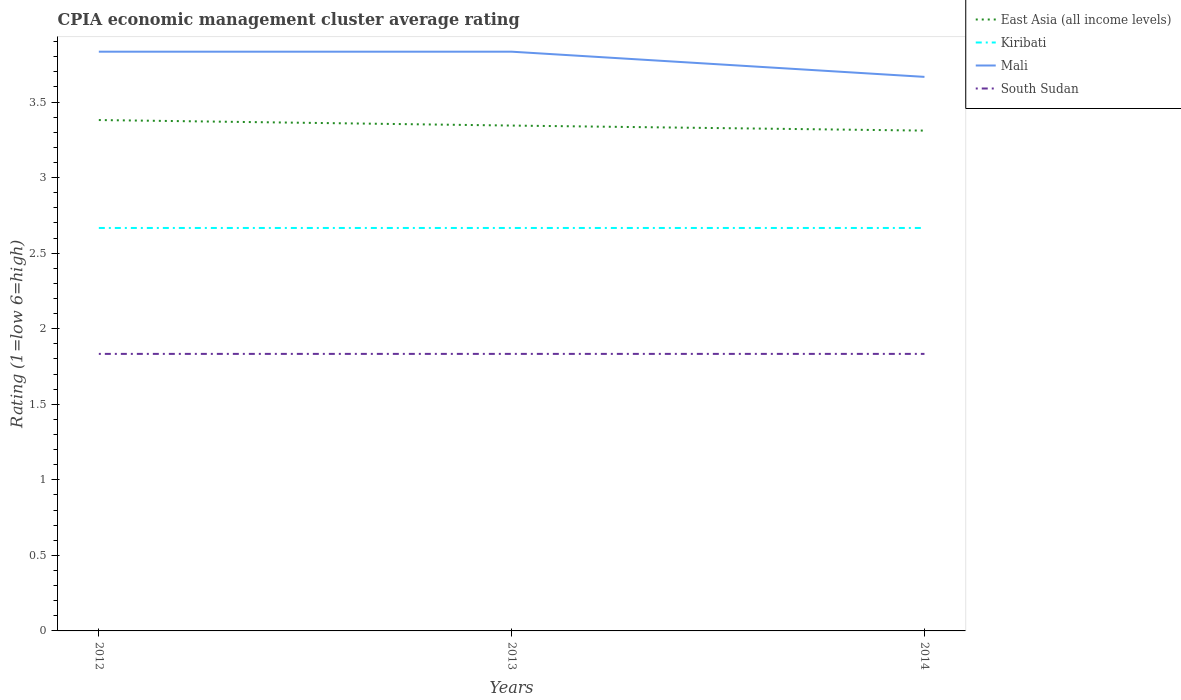Does the line corresponding to Mali intersect with the line corresponding to Kiribati?
Give a very brief answer. No. Is the number of lines equal to the number of legend labels?
Your answer should be very brief. Yes. Across all years, what is the maximum CPIA rating in East Asia (all income levels)?
Ensure brevity in your answer.  3.31. What is the total CPIA rating in Mali in the graph?
Ensure brevity in your answer.  0.17. What is the difference between the highest and the second highest CPIA rating in South Sudan?
Your answer should be very brief. 3.3333333300245016e-6. What is the difference between the highest and the lowest CPIA rating in South Sudan?
Ensure brevity in your answer.  2. Is the CPIA rating in Mali strictly greater than the CPIA rating in South Sudan over the years?
Ensure brevity in your answer.  No. How many lines are there?
Offer a very short reply. 4. Does the graph contain any zero values?
Your response must be concise. No. Where does the legend appear in the graph?
Keep it short and to the point. Top right. How many legend labels are there?
Keep it short and to the point. 4. How are the legend labels stacked?
Ensure brevity in your answer.  Vertical. What is the title of the graph?
Offer a terse response. CPIA economic management cluster average rating. What is the label or title of the X-axis?
Offer a terse response. Years. What is the label or title of the Y-axis?
Offer a very short reply. Rating (1=low 6=high). What is the Rating (1=low 6=high) in East Asia (all income levels) in 2012?
Your response must be concise. 3.38. What is the Rating (1=low 6=high) in Kiribati in 2012?
Ensure brevity in your answer.  2.67. What is the Rating (1=low 6=high) of Mali in 2012?
Your answer should be very brief. 3.83. What is the Rating (1=low 6=high) of South Sudan in 2012?
Offer a terse response. 1.83. What is the Rating (1=low 6=high) in East Asia (all income levels) in 2013?
Your response must be concise. 3.34. What is the Rating (1=low 6=high) in Kiribati in 2013?
Ensure brevity in your answer.  2.67. What is the Rating (1=low 6=high) of Mali in 2013?
Ensure brevity in your answer.  3.83. What is the Rating (1=low 6=high) in South Sudan in 2013?
Offer a very short reply. 1.83. What is the Rating (1=low 6=high) in East Asia (all income levels) in 2014?
Provide a succinct answer. 3.31. What is the Rating (1=low 6=high) of Kiribati in 2014?
Your response must be concise. 2.67. What is the Rating (1=low 6=high) in Mali in 2014?
Make the answer very short. 3.67. What is the Rating (1=low 6=high) in South Sudan in 2014?
Offer a very short reply. 1.83. Across all years, what is the maximum Rating (1=low 6=high) of East Asia (all income levels)?
Your answer should be very brief. 3.38. Across all years, what is the maximum Rating (1=low 6=high) in Kiribati?
Your answer should be compact. 2.67. Across all years, what is the maximum Rating (1=low 6=high) in Mali?
Offer a very short reply. 3.83. Across all years, what is the maximum Rating (1=low 6=high) in South Sudan?
Ensure brevity in your answer.  1.83. Across all years, what is the minimum Rating (1=low 6=high) of East Asia (all income levels)?
Make the answer very short. 3.31. Across all years, what is the minimum Rating (1=low 6=high) in Kiribati?
Give a very brief answer. 2.67. Across all years, what is the minimum Rating (1=low 6=high) in Mali?
Provide a short and direct response. 3.67. Across all years, what is the minimum Rating (1=low 6=high) in South Sudan?
Provide a short and direct response. 1.83. What is the total Rating (1=low 6=high) of East Asia (all income levels) in the graph?
Your response must be concise. 10.04. What is the total Rating (1=low 6=high) of Kiribati in the graph?
Keep it short and to the point. 8. What is the total Rating (1=low 6=high) of Mali in the graph?
Provide a short and direct response. 11.33. What is the total Rating (1=low 6=high) in South Sudan in the graph?
Provide a succinct answer. 5.5. What is the difference between the Rating (1=low 6=high) of East Asia (all income levels) in 2012 and that in 2013?
Provide a short and direct response. 0.04. What is the difference between the Rating (1=low 6=high) of South Sudan in 2012 and that in 2013?
Provide a succinct answer. 0. What is the difference between the Rating (1=low 6=high) in East Asia (all income levels) in 2012 and that in 2014?
Provide a short and direct response. 0.07. What is the difference between the Rating (1=low 6=high) in Kiribati in 2012 and that in 2014?
Provide a short and direct response. -0. What is the difference between the Rating (1=low 6=high) in South Sudan in 2012 and that in 2014?
Offer a very short reply. 0. What is the difference between the Rating (1=low 6=high) of Kiribati in 2013 and that in 2014?
Your answer should be very brief. -0. What is the difference between the Rating (1=low 6=high) in East Asia (all income levels) in 2012 and the Rating (1=low 6=high) in Mali in 2013?
Give a very brief answer. -0.45. What is the difference between the Rating (1=low 6=high) in East Asia (all income levels) in 2012 and the Rating (1=low 6=high) in South Sudan in 2013?
Provide a short and direct response. 1.55. What is the difference between the Rating (1=low 6=high) of Kiribati in 2012 and the Rating (1=low 6=high) of Mali in 2013?
Offer a terse response. -1.17. What is the difference between the Rating (1=low 6=high) in Mali in 2012 and the Rating (1=low 6=high) in South Sudan in 2013?
Offer a very short reply. 2. What is the difference between the Rating (1=low 6=high) in East Asia (all income levels) in 2012 and the Rating (1=low 6=high) in Mali in 2014?
Give a very brief answer. -0.29. What is the difference between the Rating (1=low 6=high) of East Asia (all income levels) in 2012 and the Rating (1=low 6=high) of South Sudan in 2014?
Provide a short and direct response. 1.55. What is the difference between the Rating (1=low 6=high) of Mali in 2012 and the Rating (1=low 6=high) of South Sudan in 2014?
Provide a succinct answer. 2. What is the difference between the Rating (1=low 6=high) in East Asia (all income levels) in 2013 and the Rating (1=low 6=high) in Kiribati in 2014?
Ensure brevity in your answer.  0.68. What is the difference between the Rating (1=low 6=high) in East Asia (all income levels) in 2013 and the Rating (1=low 6=high) in Mali in 2014?
Your response must be concise. -0.32. What is the difference between the Rating (1=low 6=high) of East Asia (all income levels) in 2013 and the Rating (1=low 6=high) of South Sudan in 2014?
Offer a terse response. 1.51. What is the difference between the Rating (1=low 6=high) in Mali in 2013 and the Rating (1=low 6=high) in South Sudan in 2014?
Make the answer very short. 2. What is the average Rating (1=low 6=high) in East Asia (all income levels) per year?
Offer a very short reply. 3.35. What is the average Rating (1=low 6=high) of Kiribati per year?
Your answer should be compact. 2.67. What is the average Rating (1=low 6=high) in Mali per year?
Ensure brevity in your answer.  3.78. What is the average Rating (1=low 6=high) of South Sudan per year?
Ensure brevity in your answer.  1.83. In the year 2012, what is the difference between the Rating (1=low 6=high) in East Asia (all income levels) and Rating (1=low 6=high) in Kiribati?
Make the answer very short. 0.71. In the year 2012, what is the difference between the Rating (1=low 6=high) of East Asia (all income levels) and Rating (1=low 6=high) of Mali?
Your answer should be very brief. -0.45. In the year 2012, what is the difference between the Rating (1=low 6=high) in East Asia (all income levels) and Rating (1=low 6=high) in South Sudan?
Your response must be concise. 1.55. In the year 2012, what is the difference between the Rating (1=low 6=high) in Kiribati and Rating (1=low 6=high) in Mali?
Offer a very short reply. -1.17. In the year 2012, what is the difference between the Rating (1=low 6=high) of Mali and Rating (1=low 6=high) of South Sudan?
Keep it short and to the point. 2. In the year 2013, what is the difference between the Rating (1=low 6=high) of East Asia (all income levels) and Rating (1=low 6=high) of Kiribati?
Offer a very short reply. 0.68. In the year 2013, what is the difference between the Rating (1=low 6=high) of East Asia (all income levels) and Rating (1=low 6=high) of Mali?
Make the answer very short. -0.49. In the year 2013, what is the difference between the Rating (1=low 6=high) in East Asia (all income levels) and Rating (1=low 6=high) in South Sudan?
Keep it short and to the point. 1.51. In the year 2013, what is the difference between the Rating (1=low 6=high) of Kiribati and Rating (1=low 6=high) of Mali?
Your answer should be compact. -1.17. In the year 2014, what is the difference between the Rating (1=low 6=high) in East Asia (all income levels) and Rating (1=low 6=high) in Kiribati?
Ensure brevity in your answer.  0.64. In the year 2014, what is the difference between the Rating (1=low 6=high) in East Asia (all income levels) and Rating (1=low 6=high) in Mali?
Your answer should be very brief. -0.36. In the year 2014, what is the difference between the Rating (1=low 6=high) of East Asia (all income levels) and Rating (1=low 6=high) of South Sudan?
Ensure brevity in your answer.  1.48. In the year 2014, what is the difference between the Rating (1=low 6=high) of Mali and Rating (1=low 6=high) of South Sudan?
Give a very brief answer. 1.83. What is the ratio of the Rating (1=low 6=high) of East Asia (all income levels) in 2012 to that in 2013?
Provide a short and direct response. 1.01. What is the ratio of the Rating (1=low 6=high) of Mali in 2012 to that in 2013?
Provide a succinct answer. 1. What is the ratio of the Rating (1=low 6=high) of South Sudan in 2012 to that in 2013?
Give a very brief answer. 1. What is the ratio of the Rating (1=low 6=high) of East Asia (all income levels) in 2012 to that in 2014?
Keep it short and to the point. 1.02. What is the ratio of the Rating (1=low 6=high) in Kiribati in 2012 to that in 2014?
Keep it short and to the point. 1. What is the ratio of the Rating (1=low 6=high) of Mali in 2012 to that in 2014?
Make the answer very short. 1.05. What is the ratio of the Rating (1=low 6=high) in South Sudan in 2012 to that in 2014?
Make the answer very short. 1. What is the ratio of the Rating (1=low 6=high) of Mali in 2013 to that in 2014?
Your answer should be compact. 1.05. What is the difference between the highest and the second highest Rating (1=low 6=high) in East Asia (all income levels)?
Your response must be concise. 0.04. What is the difference between the highest and the second highest Rating (1=low 6=high) of Kiribati?
Your answer should be very brief. 0. What is the difference between the highest and the second highest Rating (1=low 6=high) of Mali?
Ensure brevity in your answer.  0. What is the difference between the highest and the second highest Rating (1=low 6=high) of South Sudan?
Offer a terse response. 0. What is the difference between the highest and the lowest Rating (1=low 6=high) in East Asia (all income levels)?
Your response must be concise. 0.07. What is the difference between the highest and the lowest Rating (1=low 6=high) of Kiribati?
Provide a short and direct response. 0. What is the difference between the highest and the lowest Rating (1=low 6=high) in Mali?
Your answer should be compact. 0.17. What is the difference between the highest and the lowest Rating (1=low 6=high) of South Sudan?
Your answer should be compact. 0. 